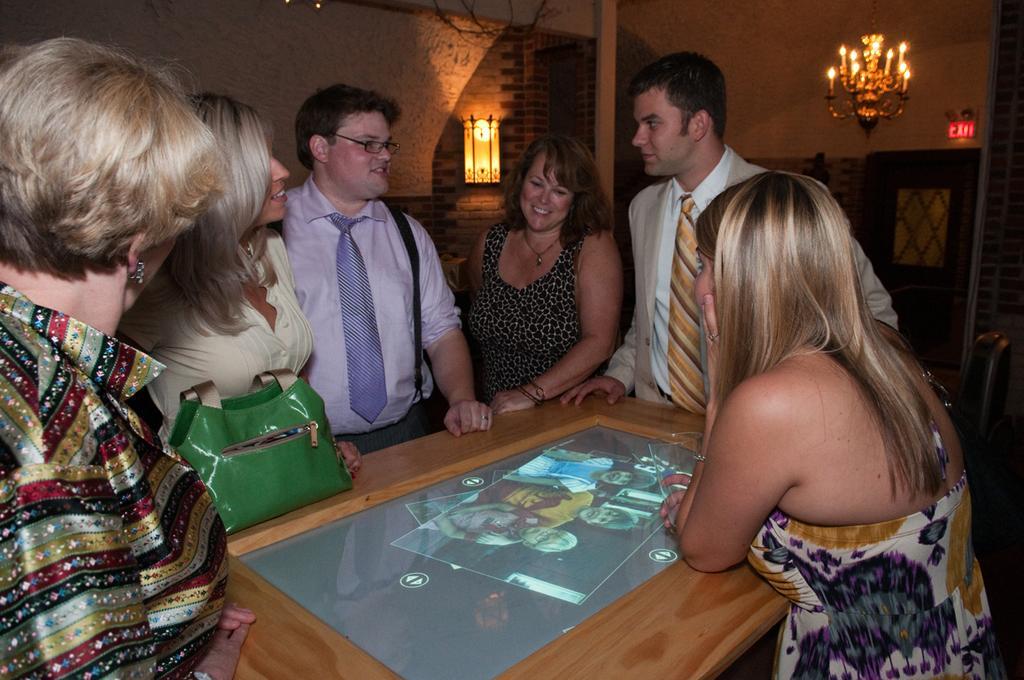Please provide a concise description of this image. There is a room which includes a chair on the right side and a group of people standing around a table. This group consists of four Women and two Men. There is a photograph and a purse placed on the top of the table. On the right side there is a Woman standing and holding a glass in her hand. In the center there is a Man and a Woman standing and smiling. In he background there is a brick wall to which a lamp is mounted and there is a hanging candle stand near to the Exit door. 